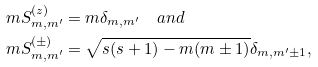<formula> <loc_0><loc_0><loc_500><loc_500>\ m S ^ { ( z ) } _ { m , m ^ { \prime } } & = m \delta _ { m , m ^ { \prime } } \quad a n d \\ \ m S ^ { ( \pm ) } _ { m , m ^ { \prime } } & = \sqrt { s ( s + 1 ) - m ( m \pm 1 ) } \delta _ { m , m ^ { \prime } \pm 1 } ,</formula> 